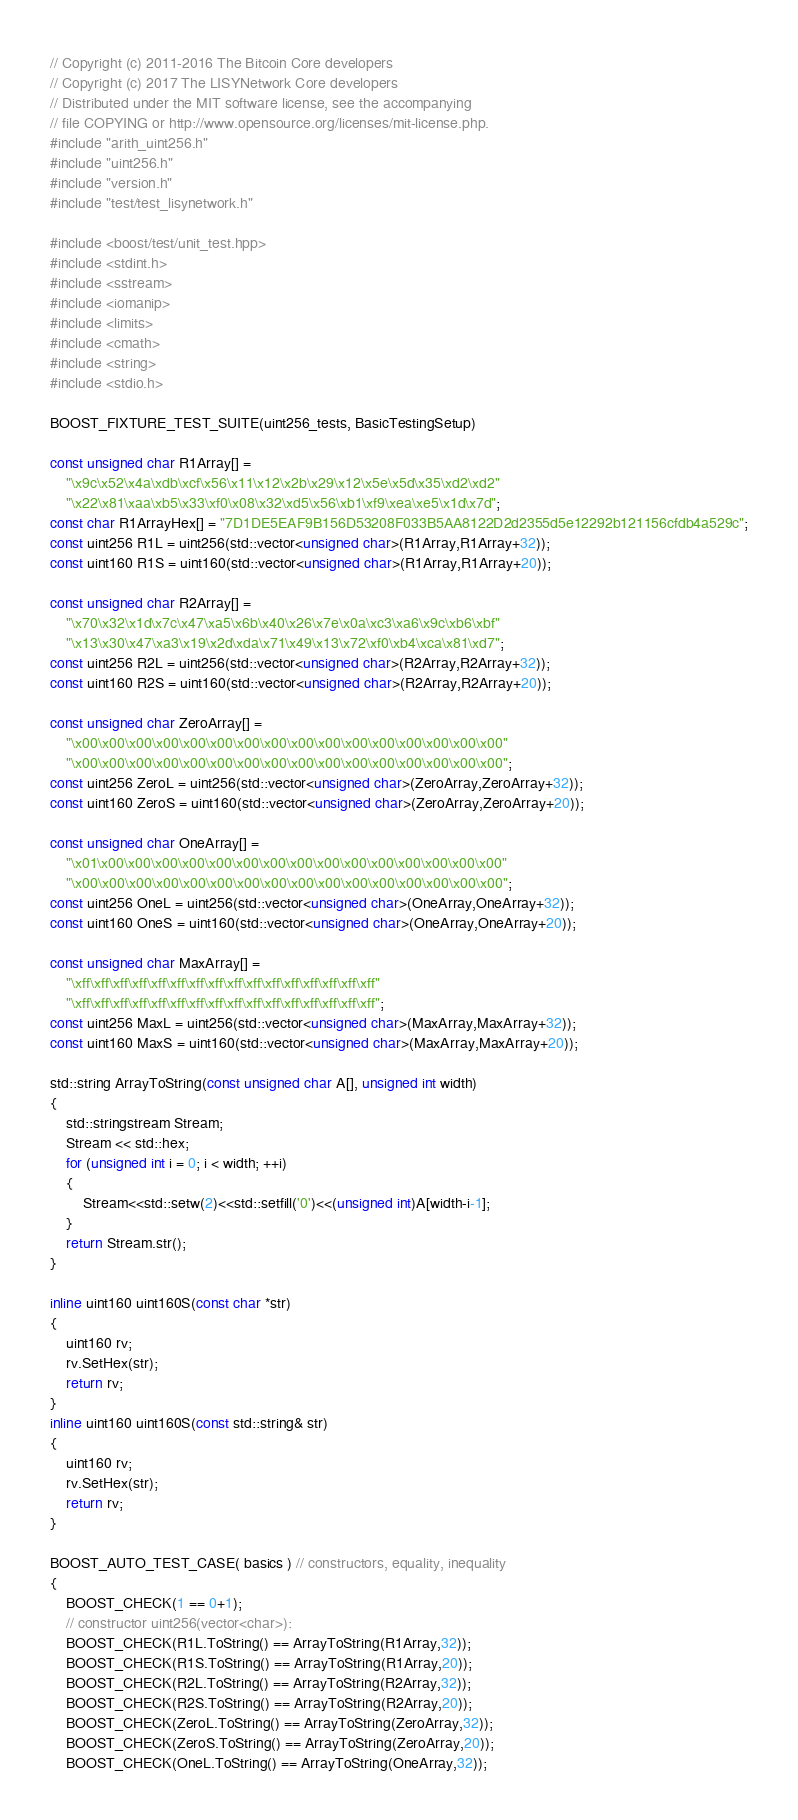Convert code to text. <code><loc_0><loc_0><loc_500><loc_500><_C++_>// Copyright (c) 2011-2016 The Bitcoin Core developers
// Copyright (c) 2017 The LISYNetwork Core developers
// Distributed under the MIT software license, see the accompanying
// file COPYING or http://www.opensource.org/licenses/mit-license.php.
#include "arith_uint256.h"
#include "uint256.h"
#include "version.h"
#include "test/test_lisynetwork.h"

#include <boost/test/unit_test.hpp>
#include <stdint.h>
#include <sstream>
#include <iomanip>
#include <limits>
#include <cmath>
#include <string>
#include <stdio.h>

BOOST_FIXTURE_TEST_SUITE(uint256_tests, BasicTestingSetup)

const unsigned char R1Array[] =
    "\x9c\x52\x4a\xdb\xcf\x56\x11\x12\x2b\x29\x12\x5e\x5d\x35\xd2\xd2"
    "\x22\x81\xaa\xb5\x33\xf0\x08\x32\xd5\x56\xb1\xf9\xea\xe5\x1d\x7d";
const char R1ArrayHex[] = "7D1DE5EAF9B156D53208F033B5AA8122D2d2355d5e12292b121156cfdb4a529c";
const uint256 R1L = uint256(std::vector<unsigned char>(R1Array,R1Array+32));
const uint160 R1S = uint160(std::vector<unsigned char>(R1Array,R1Array+20));

const unsigned char R2Array[] =
    "\x70\x32\x1d\x7c\x47\xa5\x6b\x40\x26\x7e\x0a\xc3\xa6\x9c\xb6\xbf"
    "\x13\x30\x47\xa3\x19\x2d\xda\x71\x49\x13\x72\xf0\xb4\xca\x81\xd7";
const uint256 R2L = uint256(std::vector<unsigned char>(R2Array,R2Array+32));
const uint160 R2S = uint160(std::vector<unsigned char>(R2Array,R2Array+20));

const unsigned char ZeroArray[] =
    "\x00\x00\x00\x00\x00\x00\x00\x00\x00\x00\x00\x00\x00\x00\x00\x00"
    "\x00\x00\x00\x00\x00\x00\x00\x00\x00\x00\x00\x00\x00\x00\x00\x00";
const uint256 ZeroL = uint256(std::vector<unsigned char>(ZeroArray,ZeroArray+32));
const uint160 ZeroS = uint160(std::vector<unsigned char>(ZeroArray,ZeroArray+20));

const unsigned char OneArray[] =
    "\x01\x00\x00\x00\x00\x00\x00\x00\x00\x00\x00\x00\x00\x00\x00\x00"
    "\x00\x00\x00\x00\x00\x00\x00\x00\x00\x00\x00\x00\x00\x00\x00\x00";
const uint256 OneL = uint256(std::vector<unsigned char>(OneArray,OneArray+32));
const uint160 OneS = uint160(std::vector<unsigned char>(OneArray,OneArray+20));

const unsigned char MaxArray[] =
    "\xff\xff\xff\xff\xff\xff\xff\xff\xff\xff\xff\xff\xff\xff\xff\xff"
    "\xff\xff\xff\xff\xff\xff\xff\xff\xff\xff\xff\xff\xff\xff\xff\xff";
const uint256 MaxL = uint256(std::vector<unsigned char>(MaxArray,MaxArray+32));
const uint160 MaxS = uint160(std::vector<unsigned char>(MaxArray,MaxArray+20));

std::string ArrayToString(const unsigned char A[], unsigned int width)
{
    std::stringstream Stream;
    Stream << std::hex;
    for (unsigned int i = 0; i < width; ++i)
    {
        Stream<<std::setw(2)<<std::setfill('0')<<(unsigned int)A[width-i-1];
    }
    return Stream.str();
}

inline uint160 uint160S(const char *str)
{
    uint160 rv;
    rv.SetHex(str);
    return rv;
}
inline uint160 uint160S(const std::string& str)
{
    uint160 rv;
    rv.SetHex(str);
    return rv;
}

BOOST_AUTO_TEST_CASE( basics ) // constructors, equality, inequality
{
    BOOST_CHECK(1 == 0+1);
    // constructor uint256(vector<char>):
    BOOST_CHECK(R1L.ToString() == ArrayToString(R1Array,32));
    BOOST_CHECK(R1S.ToString() == ArrayToString(R1Array,20));
    BOOST_CHECK(R2L.ToString() == ArrayToString(R2Array,32));
    BOOST_CHECK(R2S.ToString() == ArrayToString(R2Array,20));
    BOOST_CHECK(ZeroL.ToString() == ArrayToString(ZeroArray,32));
    BOOST_CHECK(ZeroS.ToString() == ArrayToString(ZeroArray,20));
    BOOST_CHECK(OneL.ToString() == ArrayToString(OneArray,32));</code> 